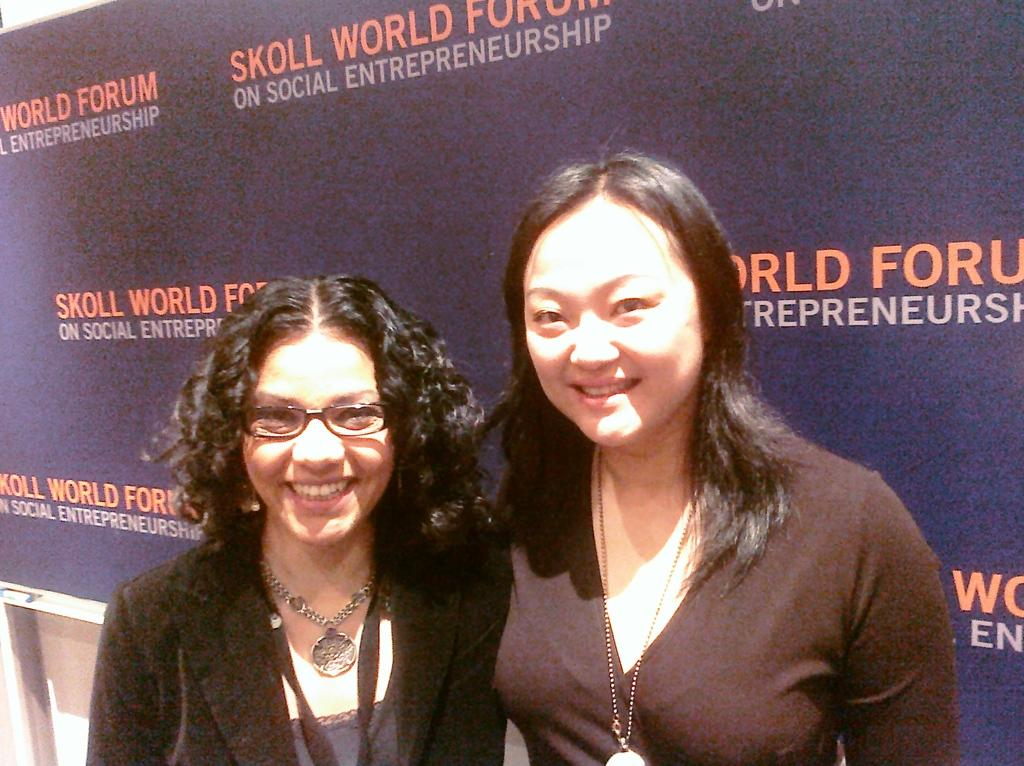How many people are in the image? There are two women in the image. What are the women doing in the image? The women are standing in front of a board. What can be seen on the board in the image? The board has text on it. What type of rice is being served in the park in the image? There is no park or rice present in the image; it features two women standing in front of a board with text on it. 